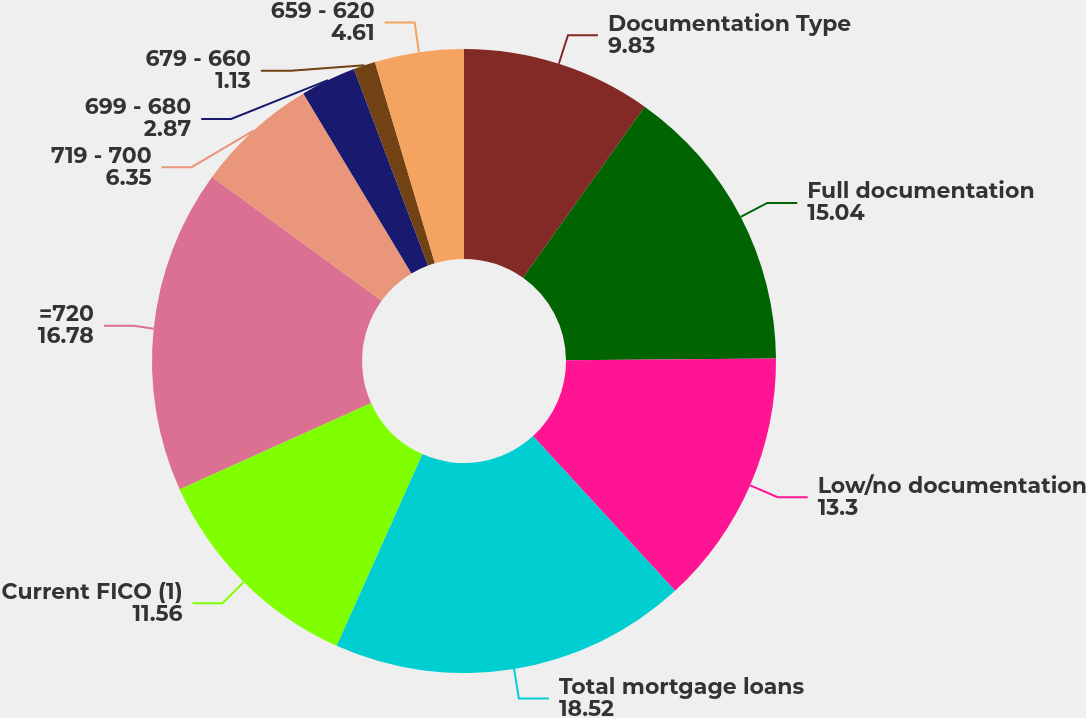Convert chart. <chart><loc_0><loc_0><loc_500><loc_500><pie_chart><fcel>Documentation Type<fcel>Full documentation<fcel>Low/no documentation<fcel>Total mortgage loans<fcel>Current FICO (1)<fcel>=720<fcel>719 - 700<fcel>699 - 680<fcel>679 - 660<fcel>659 - 620<nl><fcel>9.83%<fcel>15.04%<fcel>13.3%<fcel>18.52%<fcel>11.56%<fcel>16.78%<fcel>6.35%<fcel>2.87%<fcel>1.13%<fcel>4.61%<nl></chart> 